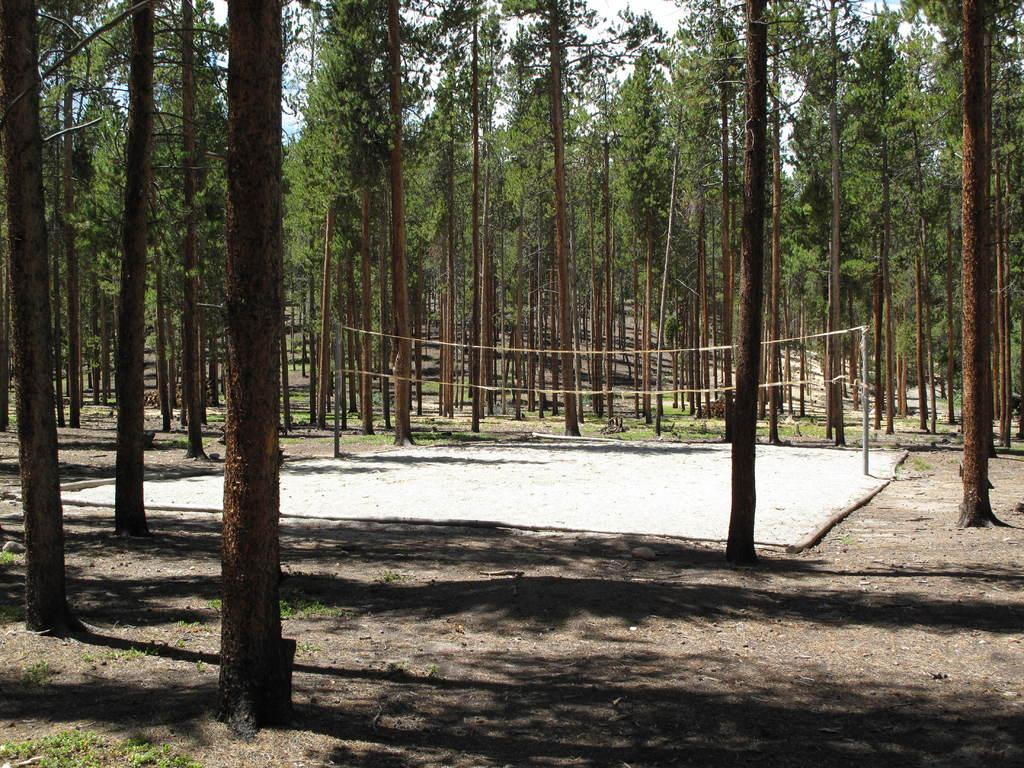What type of vegetation can be seen in the image? There are trees in the image. What sports equipment is present in the image? There is a volleyball net with poles in the image. What type of surface is visible in the image? There is sand visible in the image. What is visible in the background of the image? The sky is visible in the image. What type of land is visible in the image? There is no specific type of land mentioned in the image, only sand. Can you see any horses in the image? There are no horses present in the image. 